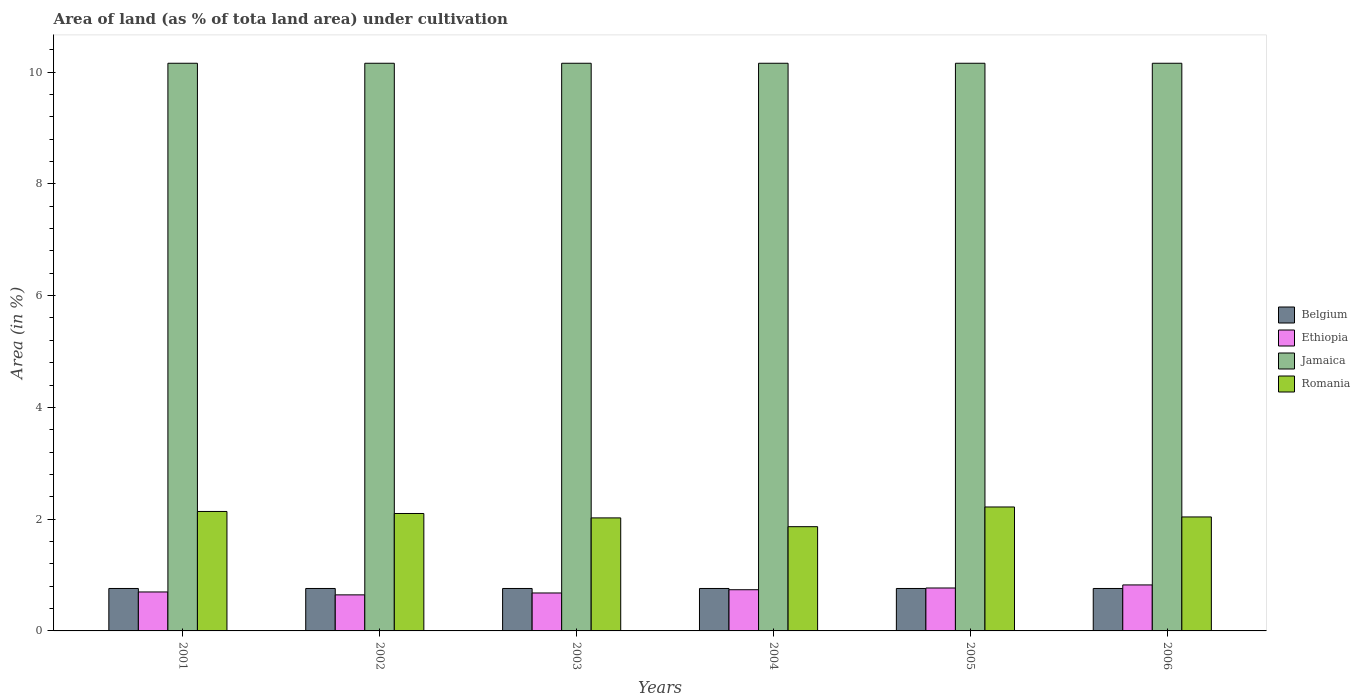How many different coloured bars are there?
Your answer should be compact. 4. Are the number of bars on each tick of the X-axis equal?
Offer a terse response. Yes. How many bars are there on the 3rd tick from the left?
Offer a very short reply. 4. How many bars are there on the 1st tick from the right?
Offer a very short reply. 4. What is the label of the 3rd group of bars from the left?
Keep it short and to the point. 2003. In how many cases, is the number of bars for a given year not equal to the number of legend labels?
Ensure brevity in your answer.  0. What is the percentage of land under cultivation in Jamaica in 2005?
Make the answer very short. 10.16. Across all years, what is the maximum percentage of land under cultivation in Jamaica?
Your response must be concise. 10.16. Across all years, what is the minimum percentage of land under cultivation in Romania?
Ensure brevity in your answer.  1.87. In which year was the percentage of land under cultivation in Belgium maximum?
Provide a succinct answer. 2001. What is the total percentage of land under cultivation in Romania in the graph?
Give a very brief answer. 12.38. What is the difference between the percentage of land under cultivation in Romania in 2002 and that in 2004?
Keep it short and to the point. 0.24. What is the difference between the percentage of land under cultivation in Belgium in 2003 and the percentage of land under cultivation in Romania in 2004?
Your response must be concise. -1.11. What is the average percentage of land under cultivation in Jamaica per year?
Your answer should be very brief. 10.16. In the year 2003, what is the difference between the percentage of land under cultivation in Belgium and percentage of land under cultivation in Ethiopia?
Keep it short and to the point. 0.08. In how many years, is the percentage of land under cultivation in Romania greater than 8.4 %?
Offer a terse response. 0. What is the ratio of the percentage of land under cultivation in Ethiopia in 2002 to that in 2006?
Offer a terse response. 0.78. Is the percentage of land under cultivation in Belgium in 2002 less than that in 2005?
Ensure brevity in your answer.  No. In how many years, is the percentage of land under cultivation in Jamaica greater than the average percentage of land under cultivation in Jamaica taken over all years?
Your response must be concise. 0. Is the sum of the percentage of land under cultivation in Jamaica in 2003 and 2005 greater than the maximum percentage of land under cultivation in Romania across all years?
Provide a succinct answer. Yes. What does the 2nd bar from the left in 2004 represents?
Offer a terse response. Ethiopia. What does the 4th bar from the right in 2001 represents?
Keep it short and to the point. Belgium. Is it the case that in every year, the sum of the percentage of land under cultivation in Jamaica and percentage of land under cultivation in Romania is greater than the percentage of land under cultivation in Ethiopia?
Keep it short and to the point. Yes. How many bars are there?
Your answer should be compact. 24. What is the difference between two consecutive major ticks on the Y-axis?
Ensure brevity in your answer.  2. Does the graph contain grids?
Your answer should be compact. No. Where does the legend appear in the graph?
Provide a short and direct response. Center right. How are the legend labels stacked?
Ensure brevity in your answer.  Vertical. What is the title of the graph?
Keep it short and to the point. Area of land (as % of tota land area) under cultivation. What is the label or title of the X-axis?
Make the answer very short. Years. What is the label or title of the Y-axis?
Provide a short and direct response. Area (in %). What is the Area (in %) in Belgium in 2001?
Your response must be concise. 0.76. What is the Area (in %) of Ethiopia in 2001?
Provide a succinct answer. 0.7. What is the Area (in %) of Jamaica in 2001?
Make the answer very short. 10.16. What is the Area (in %) in Romania in 2001?
Provide a succinct answer. 2.14. What is the Area (in %) of Belgium in 2002?
Ensure brevity in your answer.  0.76. What is the Area (in %) of Ethiopia in 2002?
Ensure brevity in your answer.  0.65. What is the Area (in %) of Jamaica in 2002?
Provide a short and direct response. 10.16. What is the Area (in %) of Romania in 2002?
Provide a succinct answer. 2.1. What is the Area (in %) in Belgium in 2003?
Your response must be concise. 0.76. What is the Area (in %) in Ethiopia in 2003?
Make the answer very short. 0.68. What is the Area (in %) in Jamaica in 2003?
Keep it short and to the point. 10.16. What is the Area (in %) of Romania in 2003?
Make the answer very short. 2.02. What is the Area (in %) of Belgium in 2004?
Ensure brevity in your answer.  0.76. What is the Area (in %) of Ethiopia in 2004?
Offer a very short reply. 0.74. What is the Area (in %) in Jamaica in 2004?
Offer a very short reply. 10.16. What is the Area (in %) of Romania in 2004?
Your answer should be very brief. 1.87. What is the Area (in %) of Belgium in 2005?
Ensure brevity in your answer.  0.76. What is the Area (in %) in Ethiopia in 2005?
Ensure brevity in your answer.  0.77. What is the Area (in %) in Jamaica in 2005?
Offer a very short reply. 10.16. What is the Area (in %) of Romania in 2005?
Ensure brevity in your answer.  2.22. What is the Area (in %) in Belgium in 2006?
Provide a succinct answer. 0.76. What is the Area (in %) in Ethiopia in 2006?
Offer a very short reply. 0.82. What is the Area (in %) in Jamaica in 2006?
Provide a succinct answer. 10.16. What is the Area (in %) of Romania in 2006?
Provide a short and direct response. 2.04. Across all years, what is the maximum Area (in %) of Belgium?
Make the answer very short. 0.76. Across all years, what is the maximum Area (in %) in Ethiopia?
Keep it short and to the point. 0.82. Across all years, what is the maximum Area (in %) of Jamaica?
Offer a very short reply. 10.16. Across all years, what is the maximum Area (in %) in Romania?
Your answer should be compact. 2.22. Across all years, what is the minimum Area (in %) of Belgium?
Provide a short and direct response. 0.76. Across all years, what is the minimum Area (in %) in Ethiopia?
Make the answer very short. 0.65. Across all years, what is the minimum Area (in %) in Jamaica?
Ensure brevity in your answer.  10.16. Across all years, what is the minimum Area (in %) of Romania?
Give a very brief answer. 1.87. What is the total Area (in %) in Belgium in the graph?
Make the answer very short. 4.56. What is the total Area (in %) in Ethiopia in the graph?
Provide a short and direct response. 4.35. What is the total Area (in %) in Jamaica in the graph?
Make the answer very short. 60.94. What is the total Area (in %) of Romania in the graph?
Your response must be concise. 12.38. What is the difference between the Area (in %) in Belgium in 2001 and that in 2002?
Give a very brief answer. 0. What is the difference between the Area (in %) of Ethiopia in 2001 and that in 2002?
Keep it short and to the point. 0.05. What is the difference between the Area (in %) in Jamaica in 2001 and that in 2002?
Your answer should be compact. 0. What is the difference between the Area (in %) of Romania in 2001 and that in 2002?
Offer a terse response. 0.04. What is the difference between the Area (in %) in Ethiopia in 2001 and that in 2003?
Offer a terse response. 0.02. What is the difference between the Area (in %) of Romania in 2001 and that in 2003?
Your answer should be very brief. 0.12. What is the difference between the Area (in %) in Ethiopia in 2001 and that in 2004?
Offer a very short reply. -0.04. What is the difference between the Area (in %) in Romania in 2001 and that in 2004?
Keep it short and to the point. 0.27. What is the difference between the Area (in %) in Belgium in 2001 and that in 2005?
Your response must be concise. 0. What is the difference between the Area (in %) in Ethiopia in 2001 and that in 2005?
Offer a terse response. -0.07. What is the difference between the Area (in %) in Romania in 2001 and that in 2005?
Keep it short and to the point. -0.08. What is the difference between the Area (in %) in Belgium in 2001 and that in 2006?
Make the answer very short. 0. What is the difference between the Area (in %) of Ethiopia in 2001 and that in 2006?
Keep it short and to the point. -0.13. What is the difference between the Area (in %) in Jamaica in 2001 and that in 2006?
Keep it short and to the point. 0. What is the difference between the Area (in %) in Romania in 2001 and that in 2006?
Offer a terse response. 0.1. What is the difference between the Area (in %) of Belgium in 2002 and that in 2003?
Ensure brevity in your answer.  0. What is the difference between the Area (in %) in Ethiopia in 2002 and that in 2003?
Ensure brevity in your answer.  -0.03. What is the difference between the Area (in %) in Romania in 2002 and that in 2003?
Give a very brief answer. 0.08. What is the difference between the Area (in %) of Ethiopia in 2002 and that in 2004?
Make the answer very short. -0.09. What is the difference between the Area (in %) in Jamaica in 2002 and that in 2004?
Give a very brief answer. 0. What is the difference between the Area (in %) of Romania in 2002 and that in 2004?
Provide a succinct answer. 0.24. What is the difference between the Area (in %) in Ethiopia in 2002 and that in 2005?
Provide a succinct answer. -0.12. What is the difference between the Area (in %) of Jamaica in 2002 and that in 2005?
Provide a succinct answer. 0. What is the difference between the Area (in %) in Romania in 2002 and that in 2005?
Make the answer very short. -0.12. What is the difference between the Area (in %) of Belgium in 2002 and that in 2006?
Offer a terse response. 0. What is the difference between the Area (in %) in Ethiopia in 2002 and that in 2006?
Ensure brevity in your answer.  -0.18. What is the difference between the Area (in %) of Jamaica in 2002 and that in 2006?
Offer a terse response. 0. What is the difference between the Area (in %) in Romania in 2002 and that in 2006?
Give a very brief answer. 0.06. What is the difference between the Area (in %) of Ethiopia in 2003 and that in 2004?
Your response must be concise. -0.06. What is the difference between the Area (in %) of Jamaica in 2003 and that in 2004?
Ensure brevity in your answer.  0. What is the difference between the Area (in %) of Romania in 2003 and that in 2004?
Your answer should be very brief. 0.16. What is the difference between the Area (in %) of Belgium in 2003 and that in 2005?
Give a very brief answer. 0. What is the difference between the Area (in %) of Ethiopia in 2003 and that in 2005?
Give a very brief answer. -0.09. What is the difference between the Area (in %) of Romania in 2003 and that in 2005?
Provide a succinct answer. -0.2. What is the difference between the Area (in %) in Belgium in 2003 and that in 2006?
Your response must be concise. 0. What is the difference between the Area (in %) of Ethiopia in 2003 and that in 2006?
Give a very brief answer. -0.14. What is the difference between the Area (in %) of Jamaica in 2003 and that in 2006?
Make the answer very short. 0. What is the difference between the Area (in %) in Romania in 2003 and that in 2006?
Provide a succinct answer. -0.02. What is the difference between the Area (in %) of Ethiopia in 2004 and that in 2005?
Provide a short and direct response. -0.03. What is the difference between the Area (in %) in Jamaica in 2004 and that in 2005?
Your response must be concise. 0. What is the difference between the Area (in %) of Romania in 2004 and that in 2005?
Ensure brevity in your answer.  -0.35. What is the difference between the Area (in %) of Ethiopia in 2004 and that in 2006?
Offer a very short reply. -0.09. What is the difference between the Area (in %) in Romania in 2004 and that in 2006?
Provide a succinct answer. -0.17. What is the difference between the Area (in %) of Ethiopia in 2005 and that in 2006?
Ensure brevity in your answer.  -0.06. What is the difference between the Area (in %) of Jamaica in 2005 and that in 2006?
Your answer should be compact. 0. What is the difference between the Area (in %) in Romania in 2005 and that in 2006?
Offer a terse response. 0.18. What is the difference between the Area (in %) of Belgium in 2001 and the Area (in %) of Ethiopia in 2002?
Offer a very short reply. 0.11. What is the difference between the Area (in %) of Belgium in 2001 and the Area (in %) of Jamaica in 2002?
Provide a succinct answer. -9.4. What is the difference between the Area (in %) in Belgium in 2001 and the Area (in %) in Romania in 2002?
Provide a succinct answer. -1.34. What is the difference between the Area (in %) in Ethiopia in 2001 and the Area (in %) in Jamaica in 2002?
Offer a very short reply. -9.46. What is the difference between the Area (in %) of Ethiopia in 2001 and the Area (in %) of Romania in 2002?
Provide a short and direct response. -1.4. What is the difference between the Area (in %) of Jamaica in 2001 and the Area (in %) of Romania in 2002?
Offer a terse response. 8.06. What is the difference between the Area (in %) of Belgium in 2001 and the Area (in %) of Ethiopia in 2003?
Offer a terse response. 0.08. What is the difference between the Area (in %) in Belgium in 2001 and the Area (in %) in Jamaica in 2003?
Provide a short and direct response. -9.4. What is the difference between the Area (in %) of Belgium in 2001 and the Area (in %) of Romania in 2003?
Offer a terse response. -1.26. What is the difference between the Area (in %) in Ethiopia in 2001 and the Area (in %) in Jamaica in 2003?
Your response must be concise. -9.46. What is the difference between the Area (in %) of Ethiopia in 2001 and the Area (in %) of Romania in 2003?
Offer a very short reply. -1.33. What is the difference between the Area (in %) of Jamaica in 2001 and the Area (in %) of Romania in 2003?
Give a very brief answer. 8.13. What is the difference between the Area (in %) of Belgium in 2001 and the Area (in %) of Ethiopia in 2004?
Offer a terse response. 0.02. What is the difference between the Area (in %) in Belgium in 2001 and the Area (in %) in Jamaica in 2004?
Provide a succinct answer. -9.4. What is the difference between the Area (in %) of Belgium in 2001 and the Area (in %) of Romania in 2004?
Your answer should be compact. -1.11. What is the difference between the Area (in %) in Ethiopia in 2001 and the Area (in %) in Jamaica in 2004?
Offer a very short reply. -9.46. What is the difference between the Area (in %) in Ethiopia in 2001 and the Area (in %) in Romania in 2004?
Provide a succinct answer. -1.17. What is the difference between the Area (in %) in Jamaica in 2001 and the Area (in %) in Romania in 2004?
Keep it short and to the point. 8.29. What is the difference between the Area (in %) of Belgium in 2001 and the Area (in %) of Ethiopia in 2005?
Offer a terse response. -0.01. What is the difference between the Area (in %) of Belgium in 2001 and the Area (in %) of Jamaica in 2005?
Make the answer very short. -9.4. What is the difference between the Area (in %) of Belgium in 2001 and the Area (in %) of Romania in 2005?
Give a very brief answer. -1.46. What is the difference between the Area (in %) of Ethiopia in 2001 and the Area (in %) of Jamaica in 2005?
Offer a very short reply. -9.46. What is the difference between the Area (in %) in Ethiopia in 2001 and the Area (in %) in Romania in 2005?
Offer a terse response. -1.52. What is the difference between the Area (in %) in Jamaica in 2001 and the Area (in %) in Romania in 2005?
Provide a succinct answer. 7.94. What is the difference between the Area (in %) in Belgium in 2001 and the Area (in %) in Ethiopia in 2006?
Your answer should be compact. -0.06. What is the difference between the Area (in %) of Belgium in 2001 and the Area (in %) of Jamaica in 2006?
Make the answer very short. -9.4. What is the difference between the Area (in %) of Belgium in 2001 and the Area (in %) of Romania in 2006?
Offer a terse response. -1.28. What is the difference between the Area (in %) of Ethiopia in 2001 and the Area (in %) of Jamaica in 2006?
Offer a terse response. -9.46. What is the difference between the Area (in %) of Ethiopia in 2001 and the Area (in %) of Romania in 2006?
Your answer should be very brief. -1.34. What is the difference between the Area (in %) of Jamaica in 2001 and the Area (in %) of Romania in 2006?
Your response must be concise. 8.12. What is the difference between the Area (in %) in Belgium in 2002 and the Area (in %) in Ethiopia in 2003?
Ensure brevity in your answer.  0.08. What is the difference between the Area (in %) of Belgium in 2002 and the Area (in %) of Jamaica in 2003?
Give a very brief answer. -9.4. What is the difference between the Area (in %) of Belgium in 2002 and the Area (in %) of Romania in 2003?
Your response must be concise. -1.26. What is the difference between the Area (in %) of Ethiopia in 2002 and the Area (in %) of Jamaica in 2003?
Make the answer very short. -9.51. What is the difference between the Area (in %) in Ethiopia in 2002 and the Area (in %) in Romania in 2003?
Your answer should be compact. -1.38. What is the difference between the Area (in %) in Jamaica in 2002 and the Area (in %) in Romania in 2003?
Provide a short and direct response. 8.13. What is the difference between the Area (in %) of Belgium in 2002 and the Area (in %) of Ethiopia in 2004?
Provide a succinct answer. 0.02. What is the difference between the Area (in %) of Belgium in 2002 and the Area (in %) of Jamaica in 2004?
Offer a very short reply. -9.4. What is the difference between the Area (in %) of Belgium in 2002 and the Area (in %) of Romania in 2004?
Your response must be concise. -1.11. What is the difference between the Area (in %) of Ethiopia in 2002 and the Area (in %) of Jamaica in 2004?
Offer a very short reply. -9.51. What is the difference between the Area (in %) of Ethiopia in 2002 and the Area (in %) of Romania in 2004?
Provide a short and direct response. -1.22. What is the difference between the Area (in %) in Jamaica in 2002 and the Area (in %) in Romania in 2004?
Make the answer very short. 8.29. What is the difference between the Area (in %) of Belgium in 2002 and the Area (in %) of Ethiopia in 2005?
Your answer should be compact. -0.01. What is the difference between the Area (in %) in Belgium in 2002 and the Area (in %) in Jamaica in 2005?
Provide a succinct answer. -9.4. What is the difference between the Area (in %) in Belgium in 2002 and the Area (in %) in Romania in 2005?
Your answer should be compact. -1.46. What is the difference between the Area (in %) in Ethiopia in 2002 and the Area (in %) in Jamaica in 2005?
Offer a very short reply. -9.51. What is the difference between the Area (in %) of Ethiopia in 2002 and the Area (in %) of Romania in 2005?
Provide a succinct answer. -1.57. What is the difference between the Area (in %) of Jamaica in 2002 and the Area (in %) of Romania in 2005?
Ensure brevity in your answer.  7.94. What is the difference between the Area (in %) in Belgium in 2002 and the Area (in %) in Ethiopia in 2006?
Offer a terse response. -0.06. What is the difference between the Area (in %) in Belgium in 2002 and the Area (in %) in Jamaica in 2006?
Offer a very short reply. -9.4. What is the difference between the Area (in %) of Belgium in 2002 and the Area (in %) of Romania in 2006?
Provide a succinct answer. -1.28. What is the difference between the Area (in %) in Ethiopia in 2002 and the Area (in %) in Jamaica in 2006?
Your response must be concise. -9.51. What is the difference between the Area (in %) in Ethiopia in 2002 and the Area (in %) in Romania in 2006?
Your response must be concise. -1.39. What is the difference between the Area (in %) of Jamaica in 2002 and the Area (in %) of Romania in 2006?
Your response must be concise. 8.12. What is the difference between the Area (in %) in Belgium in 2003 and the Area (in %) in Ethiopia in 2004?
Give a very brief answer. 0.02. What is the difference between the Area (in %) of Belgium in 2003 and the Area (in %) of Jamaica in 2004?
Make the answer very short. -9.4. What is the difference between the Area (in %) in Belgium in 2003 and the Area (in %) in Romania in 2004?
Make the answer very short. -1.11. What is the difference between the Area (in %) of Ethiopia in 2003 and the Area (in %) of Jamaica in 2004?
Your answer should be very brief. -9.48. What is the difference between the Area (in %) of Ethiopia in 2003 and the Area (in %) of Romania in 2004?
Your answer should be very brief. -1.19. What is the difference between the Area (in %) of Jamaica in 2003 and the Area (in %) of Romania in 2004?
Provide a succinct answer. 8.29. What is the difference between the Area (in %) in Belgium in 2003 and the Area (in %) in Ethiopia in 2005?
Keep it short and to the point. -0.01. What is the difference between the Area (in %) of Belgium in 2003 and the Area (in %) of Jamaica in 2005?
Keep it short and to the point. -9.4. What is the difference between the Area (in %) in Belgium in 2003 and the Area (in %) in Romania in 2005?
Ensure brevity in your answer.  -1.46. What is the difference between the Area (in %) of Ethiopia in 2003 and the Area (in %) of Jamaica in 2005?
Give a very brief answer. -9.48. What is the difference between the Area (in %) in Ethiopia in 2003 and the Area (in %) in Romania in 2005?
Offer a very short reply. -1.54. What is the difference between the Area (in %) in Jamaica in 2003 and the Area (in %) in Romania in 2005?
Provide a short and direct response. 7.94. What is the difference between the Area (in %) of Belgium in 2003 and the Area (in %) of Ethiopia in 2006?
Your answer should be compact. -0.06. What is the difference between the Area (in %) of Belgium in 2003 and the Area (in %) of Jamaica in 2006?
Your response must be concise. -9.4. What is the difference between the Area (in %) in Belgium in 2003 and the Area (in %) in Romania in 2006?
Give a very brief answer. -1.28. What is the difference between the Area (in %) of Ethiopia in 2003 and the Area (in %) of Jamaica in 2006?
Give a very brief answer. -9.48. What is the difference between the Area (in %) in Ethiopia in 2003 and the Area (in %) in Romania in 2006?
Your answer should be compact. -1.36. What is the difference between the Area (in %) in Jamaica in 2003 and the Area (in %) in Romania in 2006?
Your answer should be very brief. 8.12. What is the difference between the Area (in %) in Belgium in 2004 and the Area (in %) in Ethiopia in 2005?
Offer a terse response. -0.01. What is the difference between the Area (in %) in Belgium in 2004 and the Area (in %) in Jamaica in 2005?
Offer a very short reply. -9.4. What is the difference between the Area (in %) in Belgium in 2004 and the Area (in %) in Romania in 2005?
Your answer should be compact. -1.46. What is the difference between the Area (in %) in Ethiopia in 2004 and the Area (in %) in Jamaica in 2005?
Offer a terse response. -9.42. What is the difference between the Area (in %) in Ethiopia in 2004 and the Area (in %) in Romania in 2005?
Offer a terse response. -1.48. What is the difference between the Area (in %) in Jamaica in 2004 and the Area (in %) in Romania in 2005?
Your answer should be compact. 7.94. What is the difference between the Area (in %) in Belgium in 2004 and the Area (in %) in Ethiopia in 2006?
Provide a short and direct response. -0.06. What is the difference between the Area (in %) of Belgium in 2004 and the Area (in %) of Jamaica in 2006?
Your answer should be very brief. -9.4. What is the difference between the Area (in %) of Belgium in 2004 and the Area (in %) of Romania in 2006?
Your answer should be compact. -1.28. What is the difference between the Area (in %) of Ethiopia in 2004 and the Area (in %) of Jamaica in 2006?
Your response must be concise. -9.42. What is the difference between the Area (in %) of Ethiopia in 2004 and the Area (in %) of Romania in 2006?
Provide a succinct answer. -1.3. What is the difference between the Area (in %) in Jamaica in 2004 and the Area (in %) in Romania in 2006?
Keep it short and to the point. 8.12. What is the difference between the Area (in %) in Belgium in 2005 and the Area (in %) in Ethiopia in 2006?
Your response must be concise. -0.06. What is the difference between the Area (in %) of Belgium in 2005 and the Area (in %) of Jamaica in 2006?
Make the answer very short. -9.4. What is the difference between the Area (in %) of Belgium in 2005 and the Area (in %) of Romania in 2006?
Your response must be concise. -1.28. What is the difference between the Area (in %) in Ethiopia in 2005 and the Area (in %) in Jamaica in 2006?
Provide a succinct answer. -9.39. What is the difference between the Area (in %) in Ethiopia in 2005 and the Area (in %) in Romania in 2006?
Your response must be concise. -1.27. What is the difference between the Area (in %) in Jamaica in 2005 and the Area (in %) in Romania in 2006?
Offer a terse response. 8.12. What is the average Area (in %) in Belgium per year?
Give a very brief answer. 0.76. What is the average Area (in %) in Ethiopia per year?
Give a very brief answer. 0.72. What is the average Area (in %) of Jamaica per year?
Ensure brevity in your answer.  10.16. What is the average Area (in %) in Romania per year?
Keep it short and to the point. 2.06. In the year 2001, what is the difference between the Area (in %) of Belgium and Area (in %) of Ethiopia?
Ensure brevity in your answer.  0.06. In the year 2001, what is the difference between the Area (in %) in Belgium and Area (in %) in Jamaica?
Ensure brevity in your answer.  -9.4. In the year 2001, what is the difference between the Area (in %) in Belgium and Area (in %) in Romania?
Your response must be concise. -1.38. In the year 2001, what is the difference between the Area (in %) in Ethiopia and Area (in %) in Jamaica?
Your response must be concise. -9.46. In the year 2001, what is the difference between the Area (in %) of Ethiopia and Area (in %) of Romania?
Keep it short and to the point. -1.44. In the year 2001, what is the difference between the Area (in %) of Jamaica and Area (in %) of Romania?
Offer a terse response. 8.02. In the year 2002, what is the difference between the Area (in %) in Belgium and Area (in %) in Ethiopia?
Keep it short and to the point. 0.11. In the year 2002, what is the difference between the Area (in %) of Belgium and Area (in %) of Jamaica?
Keep it short and to the point. -9.4. In the year 2002, what is the difference between the Area (in %) in Belgium and Area (in %) in Romania?
Make the answer very short. -1.34. In the year 2002, what is the difference between the Area (in %) of Ethiopia and Area (in %) of Jamaica?
Your answer should be compact. -9.51. In the year 2002, what is the difference between the Area (in %) in Ethiopia and Area (in %) in Romania?
Make the answer very short. -1.46. In the year 2002, what is the difference between the Area (in %) in Jamaica and Area (in %) in Romania?
Offer a very short reply. 8.06. In the year 2003, what is the difference between the Area (in %) in Belgium and Area (in %) in Ethiopia?
Offer a very short reply. 0.08. In the year 2003, what is the difference between the Area (in %) in Belgium and Area (in %) in Jamaica?
Make the answer very short. -9.4. In the year 2003, what is the difference between the Area (in %) in Belgium and Area (in %) in Romania?
Your answer should be compact. -1.26. In the year 2003, what is the difference between the Area (in %) of Ethiopia and Area (in %) of Jamaica?
Give a very brief answer. -9.48. In the year 2003, what is the difference between the Area (in %) of Ethiopia and Area (in %) of Romania?
Your response must be concise. -1.34. In the year 2003, what is the difference between the Area (in %) in Jamaica and Area (in %) in Romania?
Your answer should be compact. 8.13. In the year 2004, what is the difference between the Area (in %) in Belgium and Area (in %) in Ethiopia?
Offer a very short reply. 0.02. In the year 2004, what is the difference between the Area (in %) of Belgium and Area (in %) of Jamaica?
Ensure brevity in your answer.  -9.4. In the year 2004, what is the difference between the Area (in %) of Belgium and Area (in %) of Romania?
Keep it short and to the point. -1.11. In the year 2004, what is the difference between the Area (in %) of Ethiopia and Area (in %) of Jamaica?
Provide a short and direct response. -9.42. In the year 2004, what is the difference between the Area (in %) of Ethiopia and Area (in %) of Romania?
Ensure brevity in your answer.  -1.13. In the year 2004, what is the difference between the Area (in %) in Jamaica and Area (in %) in Romania?
Provide a succinct answer. 8.29. In the year 2005, what is the difference between the Area (in %) of Belgium and Area (in %) of Ethiopia?
Offer a very short reply. -0.01. In the year 2005, what is the difference between the Area (in %) of Belgium and Area (in %) of Jamaica?
Your answer should be very brief. -9.4. In the year 2005, what is the difference between the Area (in %) in Belgium and Area (in %) in Romania?
Keep it short and to the point. -1.46. In the year 2005, what is the difference between the Area (in %) in Ethiopia and Area (in %) in Jamaica?
Give a very brief answer. -9.39. In the year 2005, what is the difference between the Area (in %) in Ethiopia and Area (in %) in Romania?
Provide a succinct answer. -1.45. In the year 2005, what is the difference between the Area (in %) of Jamaica and Area (in %) of Romania?
Ensure brevity in your answer.  7.94. In the year 2006, what is the difference between the Area (in %) in Belgium and Area (in %) in Ethiopia?
Provide a succinct answer. -0.06. In the year 2006, what is the difference between the Area (in %) of Belgium and Area (in %) of Jamaica?
Your answer should be compact. -9.4. In the year 2006, what is the difference between the Area (in %) of Belgium and Area (in %) of Romania?
Offer a very short reply. -1.28. In the year 2006, what is the difference between the Area (in %) in Ethiopia and Area (in %) in Jamaica?
Give a very brief answer. -9.33. In the year 2006, what is the difference between the Area (in %) of Ethiopia and Area (in %) of Romania?
Your answer should be very brief. -1.22. In the year 2006, what is the difference between the Area (in %) of Jamaica and Area (in %) of Romania?
Provide a succinct answer. 8.12. What is the ratio of the Area (in %) in Ethiopia in 2001 to that in 2002?
Your answer should be compact. 1.08. What is the ratio of the Area (in %) in Jamaica in 2001 to that in 2002?
Your answer should be very brief. 1. What is the ratio of the Area (in %) of Romania in 2001 to that in 2002?
Offer a very short reply. 1.02. What is the ratio of the Area (in %) of Ethiopia in 2001 to that in 2003?
Your answer should be compact. 1.03. What is the ratio of the Area (in %) in Romania in 2001 to that in 2003?
Provide a succinct answer. 1.06. What is the ratio of the Area (in %) of Belgium in 2001 to that in 2004?
Provide a short and direct response. 1. What is the ratio of the Area (in %) in Ethiopia in 2001 to that in 2004?
Keep it short and to the point. 0.95. What is the ratio of the Area (in %) in Romania in 2001 to that in 2004?
Your answer should be very brief. 1.15. What is the ratio of the Area (in %) in Belgium in 2001 to that in 2005?
Ensure brevity in your answer.  1. What is the ratio of the Area (in %) of Ethiopia in 2001 to that in 2005?
Make the answer very short. 0.91. What is the ratio of the Area (in %) in Jamaica in 2001 to that in 2005?
Provide a short and direct response. 1. What is the ratio of the Area (in %) of Romania in 2001 to that in 2005?
Your response must be concise. 0.96. What is the ratio of the Area (in %) in Belgium in 2001 to that in 2006?
Give a very brief answer. 1. What is the ratio of the Area (in %) of Ethiopia in 2001 to that in 2006?
Your answer should be compact. 0.85. What is the ratio of the Area (in %) of Jamaica in 2001 to that in 2006?
Offer a terse response. 1. What is the ratio of the Area (in %) in Romania in 2001 to that in 2006?
Provide a short and direct response. 1.05. What is the ratio of the Area (in %) of Ethiopia in 2002 to that in 2003?
Your response must be concise. 0.95. What is the ratio of the Area (in %) in Romania in 2002 to that in 2003?
Give a very brief answer. 1.04. What is the ratio of the Area (in %) in Ethiopia in 2002 to that in 2004?
Ensure brevity in your answer.  0.88. What is the ratio of the Area (in %) in Jamaica in 2002 to that in 2004?
Your answer should be compact. 1. What is the ratio of the Area (in %) in Romania in 2002 to that in 2004?
Make the answer very short. 1.13. What is the ratio of the Area (in %) in Ethiopia in 2002 to that in 2005?
Provide a short and direct response. 0.84. What is the ratio of the Area (in %) of Jamaica in 2002 to that in 2005?
Offer a terse response. 1. What is the ratio of the Area (in %) in Romania in 2002 to that in 2005?
Your answer should be very brief. 0.95. What is the ratio of the Area (in %) in Belgium in 2002 to that in 2006?
Your answer should be compact. 1. What is the ratio of the Area (in %) in Ethiopia in 2002 to that in 2006?
Your answer should be compact. 0.78. What is the ratio of the Area (in %) of Jamaica in 2002 to that in 2006?
Provide a succinct answer. 1. What is the ratio of the Area (in %) of Romania in 2002 to that in 2006?
Offer a very short reply. 1.03. What is the ratio of the Area (in %) in Belgium in 2003 to that in 2004?
Your response must be concise. 1. What is the ratio of the Area (in %) in Ethiopia in 2003 to that in 2004?
Keep it short and to the point. 0.92. What is the ratio of the Area (in %) in Jamaica in 2003 to that in 2004?
Keep it short and to the point. 1. What is the ratio of the Area (in %) of Romania in 2003 to that in 2004?
Give a very brief answer. 1.08. What is the ratio of the Area (in %) of Belgium in 2003 to that in 2005?
Give a very brief answer. 1. What is the ratio of the Area (in %) in Ethiopia in 2003 to that in 2005?
Keep it short and to the point. 0.88. What is the ratio of the Area (in %) in Jamaica in 2003 to that in 2005?
Offer a terse response. 1. What is the ratio of the Area (in %) of Romania in 2003 to that in 2005?
Provide a succinct answer. 0.91. What is the ratio of the Area (in %) of Ethiopia in 2003 to that in 2006?
Provide a succinct answer. 0.82. What is the ratio of the Area (in %) of Ethiopia in 2004 to that in 2005?
Give a very brief answer. 0.96. What is the ratio of the Area (in %) in Jamaica in 2004 to that in 2005?
Provide a short and direct response. 1. What is the ratio of the Area (in %) of Romania in 2004 to that in 2005?
Your response must be concise. 0.84. What is the ratio of the Area (in %) in Ethiopia in 2004 to that in 2006?
Your response must be concise. 0.9. What is the ratio of the Area (in %) of Romania in 2004 to that in 2006?
Your response must be concise. 0.91. What is the ratio of the Area (in %) of Belgium in 2005 to that in 2006?
Provide a short and direct response. 1. What is the ratio of the Area (in %) in Ethiopia in 2005 to that in 2006?
Make the answer very short. 0.93. What is the ratio of the Area (in %) of Jamaica in 2005 to that in 2006?
Ensure brevity in your answer.  1. What is the ratio of the Area (in %) in Romania in 2005 to that in 2006?
Offer a terse response. 1.09. What is the difference between the highest and the second highest Area (in %) of Ethiopia?
Your answer should be compact. 0.06. What is the difference between the highest and the second highest Area (in %) in Jamaica?
Give a very brief answer. 0. What is the difference between the highest and the second highest Area (in %) of Romania?
Give a very brief answer. 0.08. What is the difference between the highest and the lowest Area (in %) of Belgium?
Your answer should be very brief. 0. What is the difference between the highest and the lowest Area (in %) of Ethiopia?
Offer a terse response. 0.18. What is the difference between the highest and the lowest Area (in %) in Jamaica?
Make the answer very short. 0. What is the difference between the highest and the lowest Area (in %) of Romania?
Ensure brevity in your answer.  0.35. 